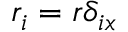<formula> <loc_0><loc_0><loc_500><loc_500>r _ { i } = r \delta _ { i x }</formula> 